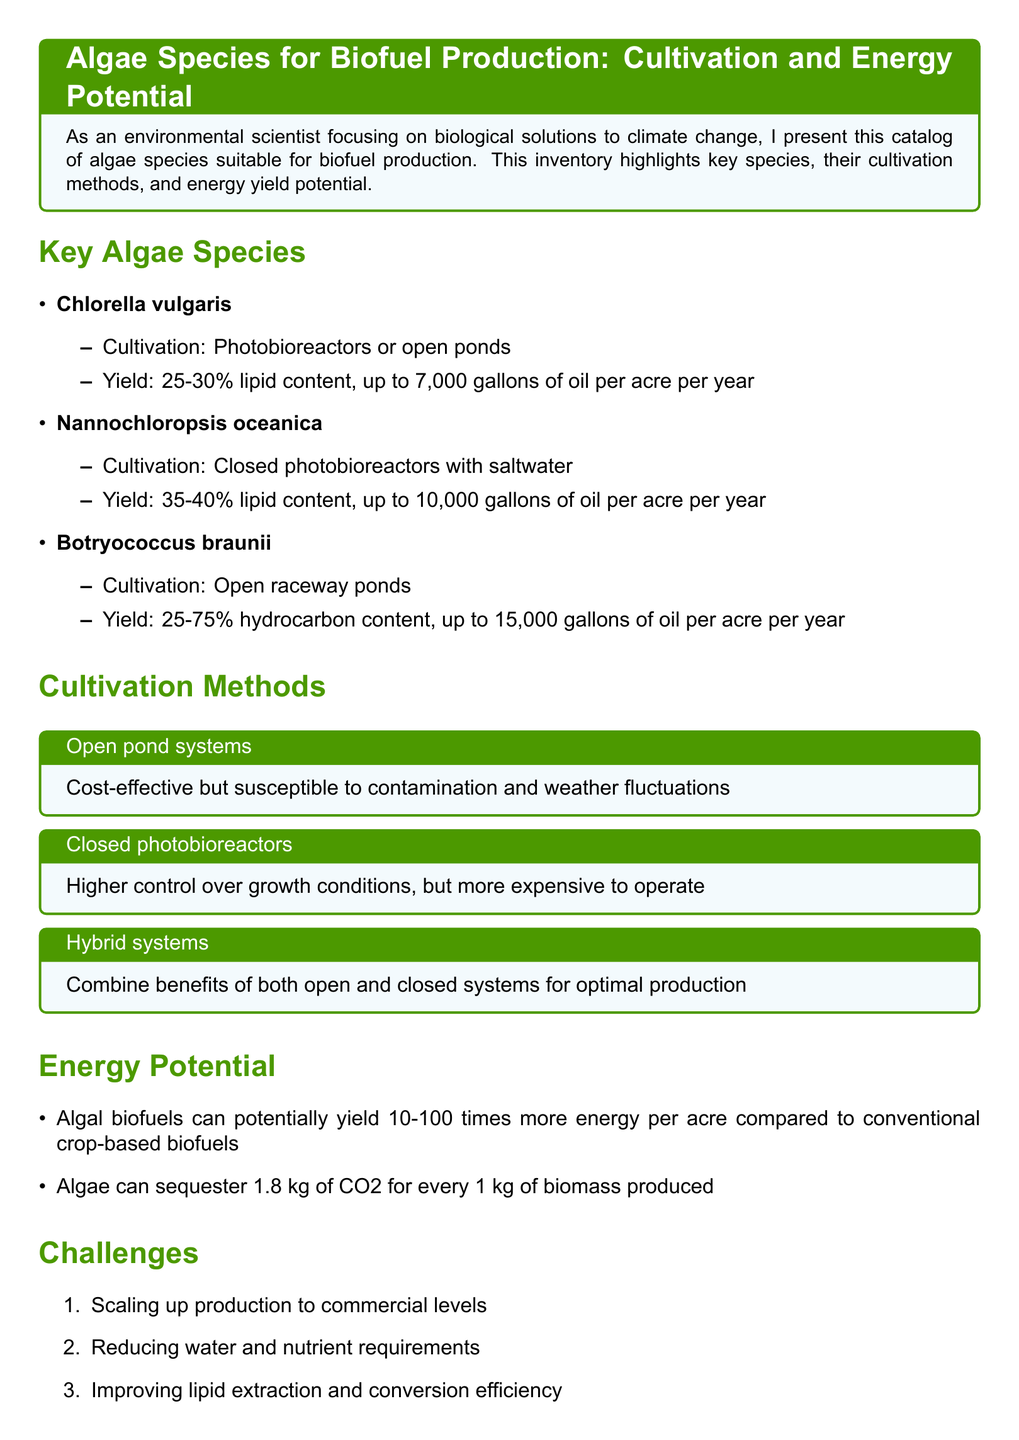What is the lipid content of Nannochloropsis oceanica? The lipid content of Nannochloropsis oceanica is specified in the document as 35-40%.
Answer: 35-40% How many gallons of oil can Botryococcus braunii yield per acre per year? The document states that Botryococcus braunii can yield up to 15,000 gallons of oil per acre per year.
Answer: 15,000 What are the two types of cultivation methods mentioned? The cultivation methods discussed include open pond systems and closed photobioreactors, among others.
Answer: Open pond systems, closed photobioreactors Which algae species has the highest potential oil yield? The document indicates that the algae species with the highest oil yield is Botryococcus braunii, which can yield up to 15,000 gallons.
Answer: Botryococcus braunii What is one challenge listed for algal biofuel production? Among the challenges mentioned, one is scaling up production to commercial levels.
Answer: Scaling up production to commercial levels What is the potential energy yield comparison of algal biofuels versus conventional crop-based biofuels? The document states that algal biofuels can yield 10-100 times more energy per acre.
Answer: 10-100 times more energy per acre In what type of systems is the cultivation of Chlorella vulgaris primarily conducted? The cultivation methods for Chlorella vulgaris are conducted primarily in photobioreactors or open ponds as per the document.
Answer: Photobioreactors or open ponds 